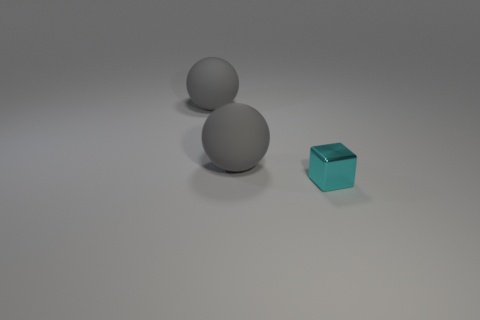What is the tiny cyan cube made of?
Ensure brevity in your answer.  Metal. Is there anything else that is the same color as the shiny block?
Provide a short and direct response. No. What is the color of the tiny shiny object?
Provide a short and direct response. Cyan. Are there any small cyan shiny objects behind the tiny cyan metallic cube?
Give a very brief answer. No. How many other things are there of the same material as the cyan cube?
Offer a very short reply. 0. Is the number of rubber objects in front of the small object greater than the number of cyan blocks?
Your answer should be compact. No. Is there another cyan thing of the same shape as the cyan metallic thing?
Provide a succinct answer. No. How many things are things that are behind the small cyan object or cyan cubes?
Your answer should be very brief. 3. Is the number of cyan objects greater than the number of big rubber things?
Your response must be concise. No. Are there any cubes that have the same size as the cyan metal thing?
Give a very brief answer. No. 